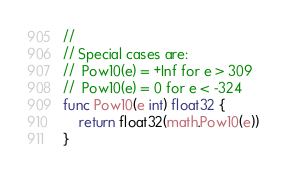<code> <loc_0><loc_0><loc_500><loc_500><_Go_>//
// Special cases are:
//	Pow10(e) = +Inf for e > 309
//	Pow10(e) = 0 for e < -324
func Pow10(e int) float32 {
	return float32(math.Pow10(e))
}
</code> 